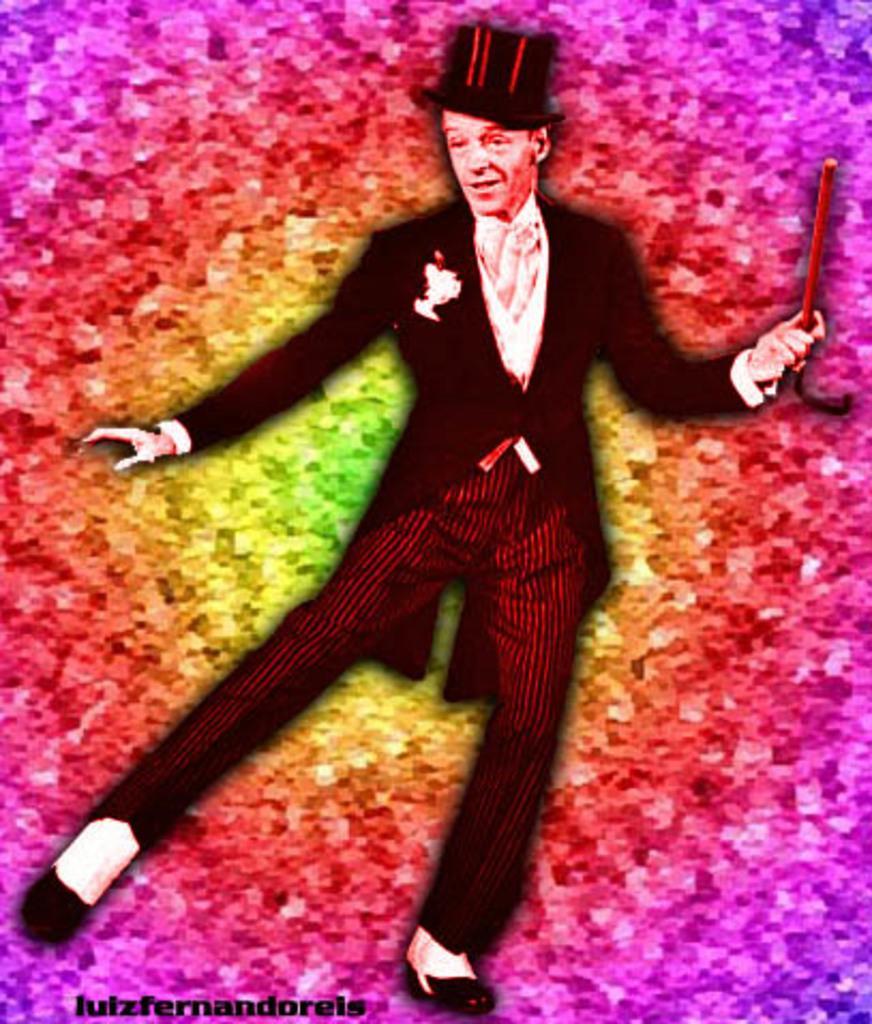Can you describe this image briefly? In this image, there is there is a person wearing clothes and hat on the colorful background. This person is holding a stick with his hand. 